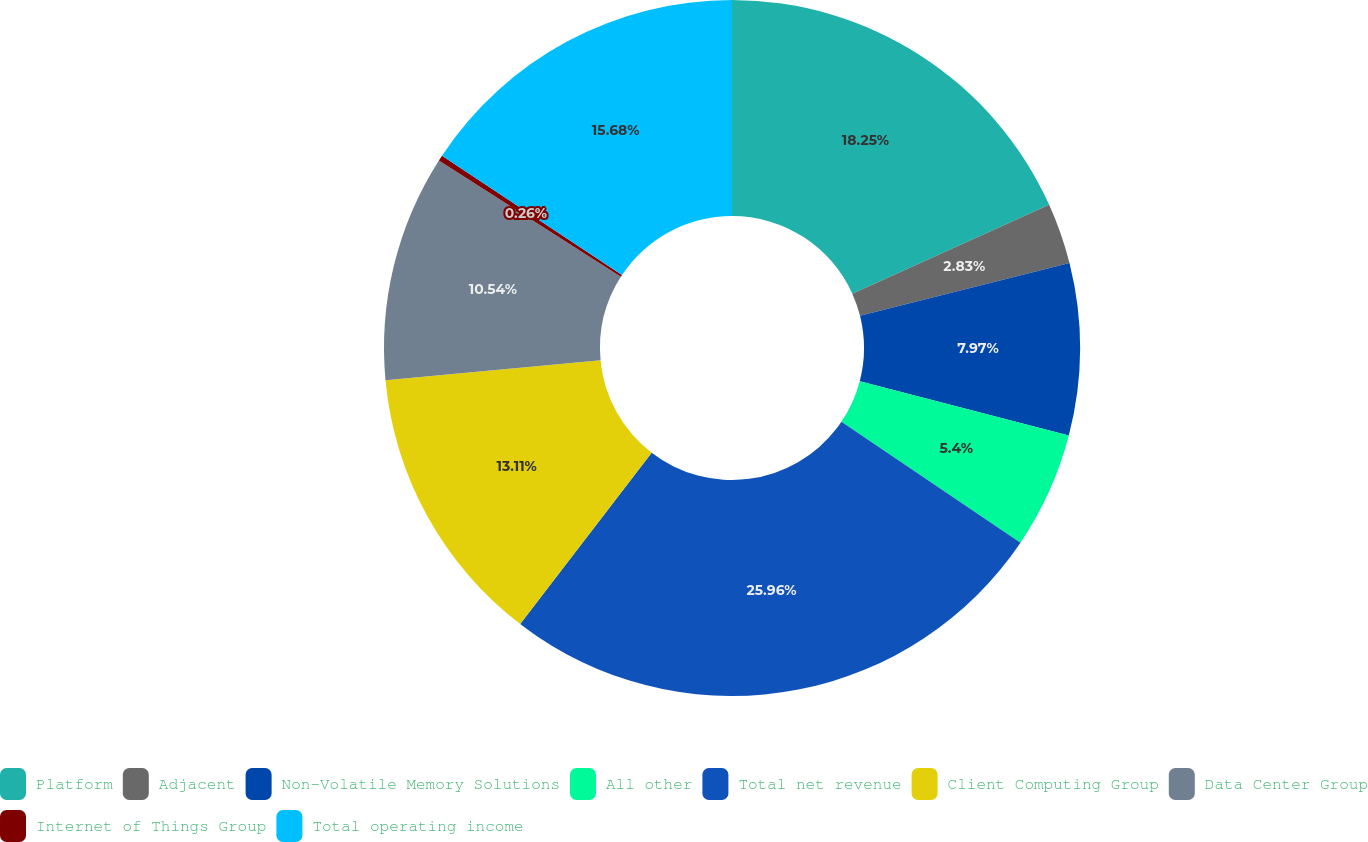Convert chart. <chart><loc_0><loc_0><loc_500><loc_500><pie_chart><fcel>Platform<fcel>Adjacent<fcel>Non-Volatile Memory Solutions<fcel>All other<fcel>Total net revenue<fcel>Client Computing Group<fcel>Data Center Group<fcel>Internet of Things Group<fcel>Total operating income<nl><fcel>18.25%<fcel>2.83%<fcel>7.97%<fcel>5.4%<fcel>25.97%<fcel>13.11%<fcel>10.54%<fcel>0.26%<fcel>15.68%<nl></chart> 